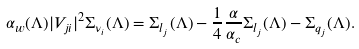Convert formula to latex. <formula><loc_0><loc_0><loc_500><loc_500>\alpha _ { w } ( \Lambda ) | V _ { j i } | ^ { 2 } \Sigma _ { \nu _ { i } } ( \Lambda ) = \Sigma _ { l _ { j } } ( \Lambda ) - { \frac { 1 } { 4 } } { \frac { \alpha } { \alpha _ { c } } } \Sigma _ { l _ { j } } ( \Lambda ) - \Sigma _ { q _ { j } } ( \Lambda ) .</formula> 